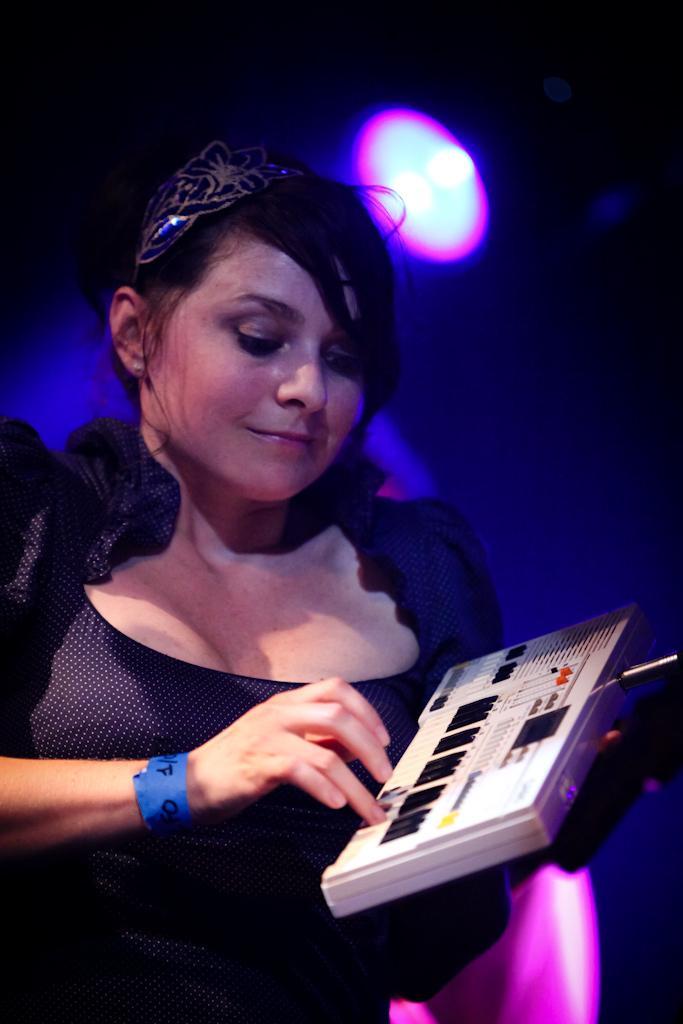How would you summarize this image in a sentence or two? In the picture we can see a woman standing in the black dress and playing a musical instrument, and to the ceiling we can see the light. 